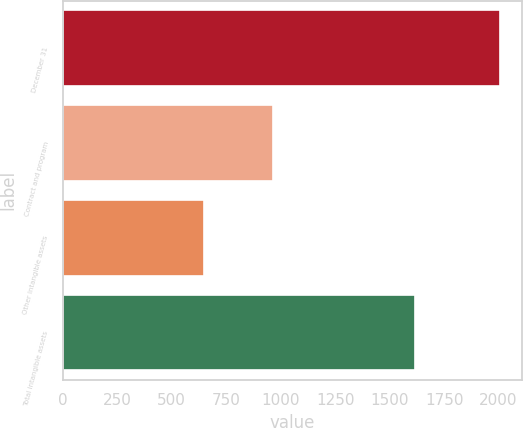<chart> <loc_0><loc_0><loc_500><loc_500><bar_chart><fcel>December 31<fcel>Contract and program<fcel>Other intangible assets<fcel>Total intangible assets<nl><fcel>2008<fcel>967<fcel>650<fcel>1617<nl></chart> 